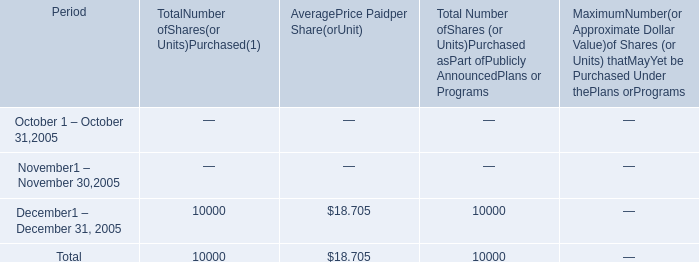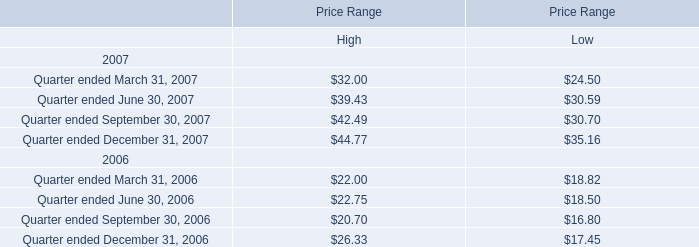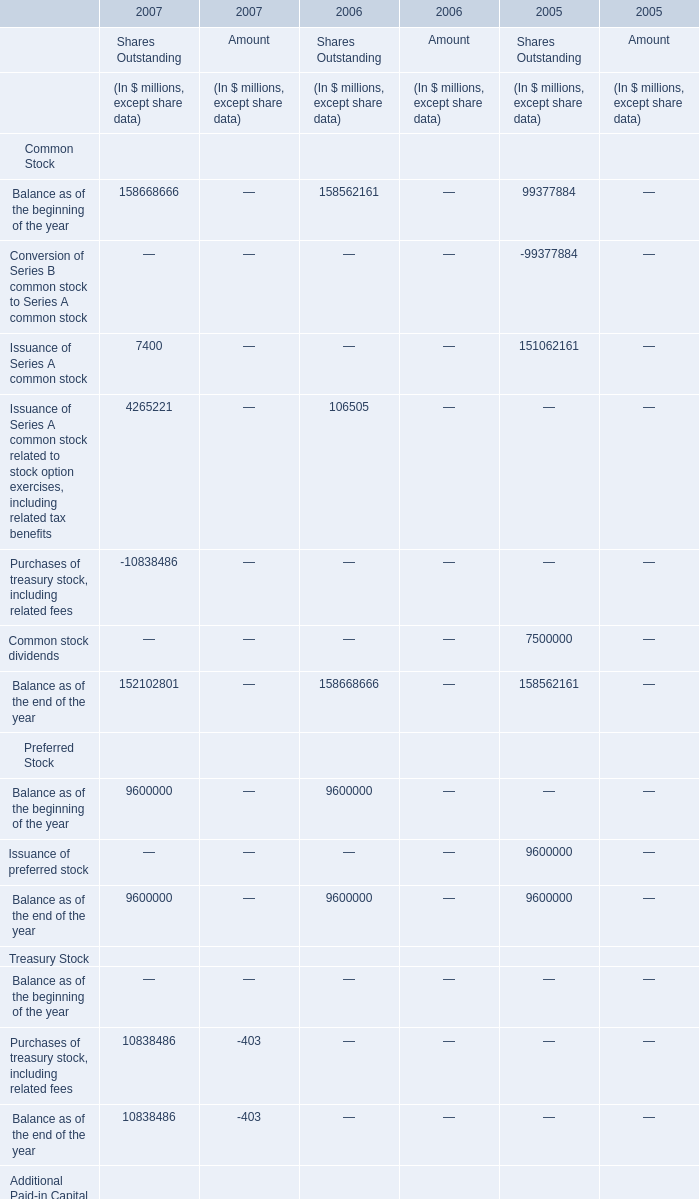What's the increasing rate of Balance as of the beginning of the year of Shares Outstanding in 2007? 
Computations: ((158668666 - 158562161) / 158562161)
Answer: 0.00067. 